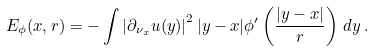Convert formula to latex. <formula><loc_0><loc_0><loc_500><loc_500>E _ { \phi } ( x , r ) = - \int \left | \partial _ { \nu _ { x } } u ( y ) \right | ^ { 2 } | y - x | \phi ^ { \prime } \left ( { \frac { | y - x | } { r } } \right ) \, d y \, .</formula> 